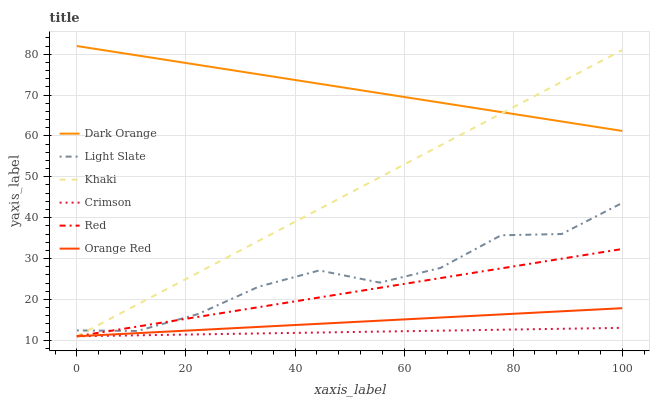Does Crimson have the minimum area under the curve?
Answer yes or no. Yes. Does Dark Orange have the maximum area under the curve?
Answer yes or no. Yes. Does Khaki have the minimum area under the curve?
Answer yes or no. No. Does Khaki have the maximum area under the curve?
Answer yes or no. No. Is Crimson the smoothest?
Answer yes or no. Yes. Is Light Slate the roughest?
Answer yes or no. Yes. Is Khaki the smoothest?
Answer yes or no. No. Is Khaki the roughest?
Answer yes or no. No. Does Khaki have the lowest value?
Answer yes or no. Yes. Does Light Slate have the lowest value?
Answer yes or no. No. Does Dark Orange have the highest value?
Answer yes or no. Yes. Does Khaki have the highest value?
Answer yes or no. No. Is Orange Red less than Light Slate?
Answer yes or no. Yes. Is Dark Orange greater than Crimson?
Answer yes or no. Yes. Does Khaki intersect Dark Orange?
Answer yes or no. Yes. Is Khaki less than Dark Orange?
Answer yes or no. No. Is Khaki greater than Dark Orange?
Answer yes or no. No. Does Orange Red intersect Light Slate?
Answer yes or no. No. 